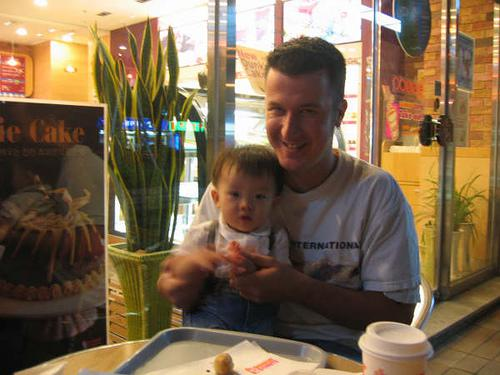Question: what is in the cup?
Choices:
A. Water.
B. Nothing.
C. Juice.
D. Coffee.
Answer with the letter. Answer: D Question: how many donuts are there?
Choices:
A. 1 donut hole.
B. 2.
C. 3.
D. 4.
Answer with the letter. Answer: A 